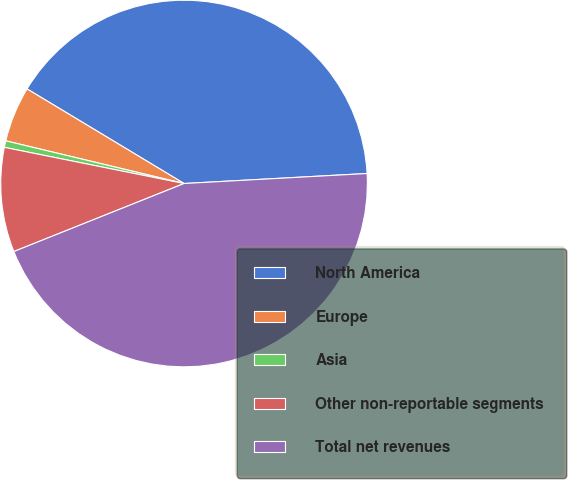Convert chart. <chart><loc_0><loc_0><loc_500><loc_500><pie_chart><fcel>North America<fcel>Europe<fcel>Asia<fcel>Other non-reportable segments<fcel>Total net revenues<nl><fcel>40.5%<fcel>4.89%<fcel>0.58%<fcel>9.21%<fcel>44.82%<nl></chart> 